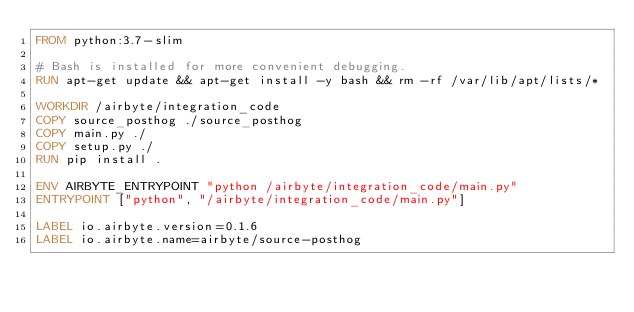Convert code to text. <code><loc_0><loc_0><loc_500><loc_500><_Dockerfile_>FROM python:3.7-slim

# Bash is installed for more convenient debugging.
RUN apt-get update && apt-get install -y bash && rm -rf /var/lib/apt/lists/*

WORKDIR /airbyte/integration_code
COPY source_posthog ./source_posthog
COPY main.py ./
COPY setup.py ./
RUN pip install .

ENV AIRBYTE_ENTRYPOINT "python /airbyte/integration_code/main.py"
ENTRYPOINT ["python", "/airbyte/integration_code/main.py"]

LABEL io.airbyte.version=0.1.6
LABEL io.airbyte.name=airbyte/source-posthog
</code> 